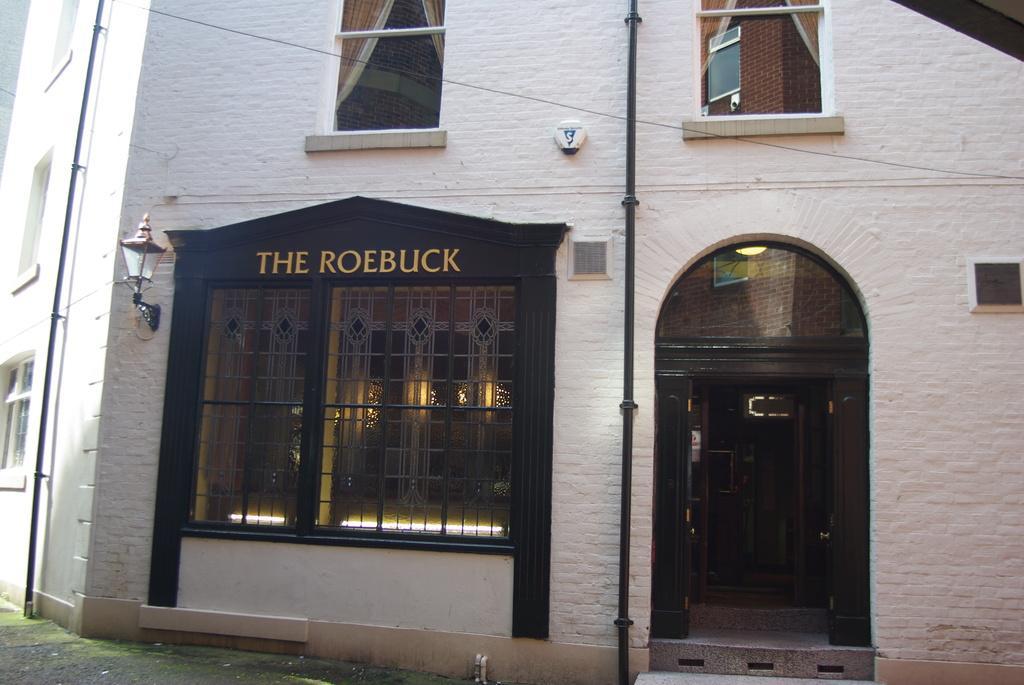Please provide a concise description of this image. In this image I can see the buildings with windows and light. I can also see the black color pipe to the building. I can see something is written on it. I can see the curtains through the window. 